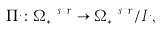<formula> <loc_0><loc_0><loc_500><loc_500>\Pi _ { i } \colon \Omega ^ { \ s t r } _ { * } \rightarrow \Omega ^ { \ s t r } _ { * } / I _ { i } ,</formula> 